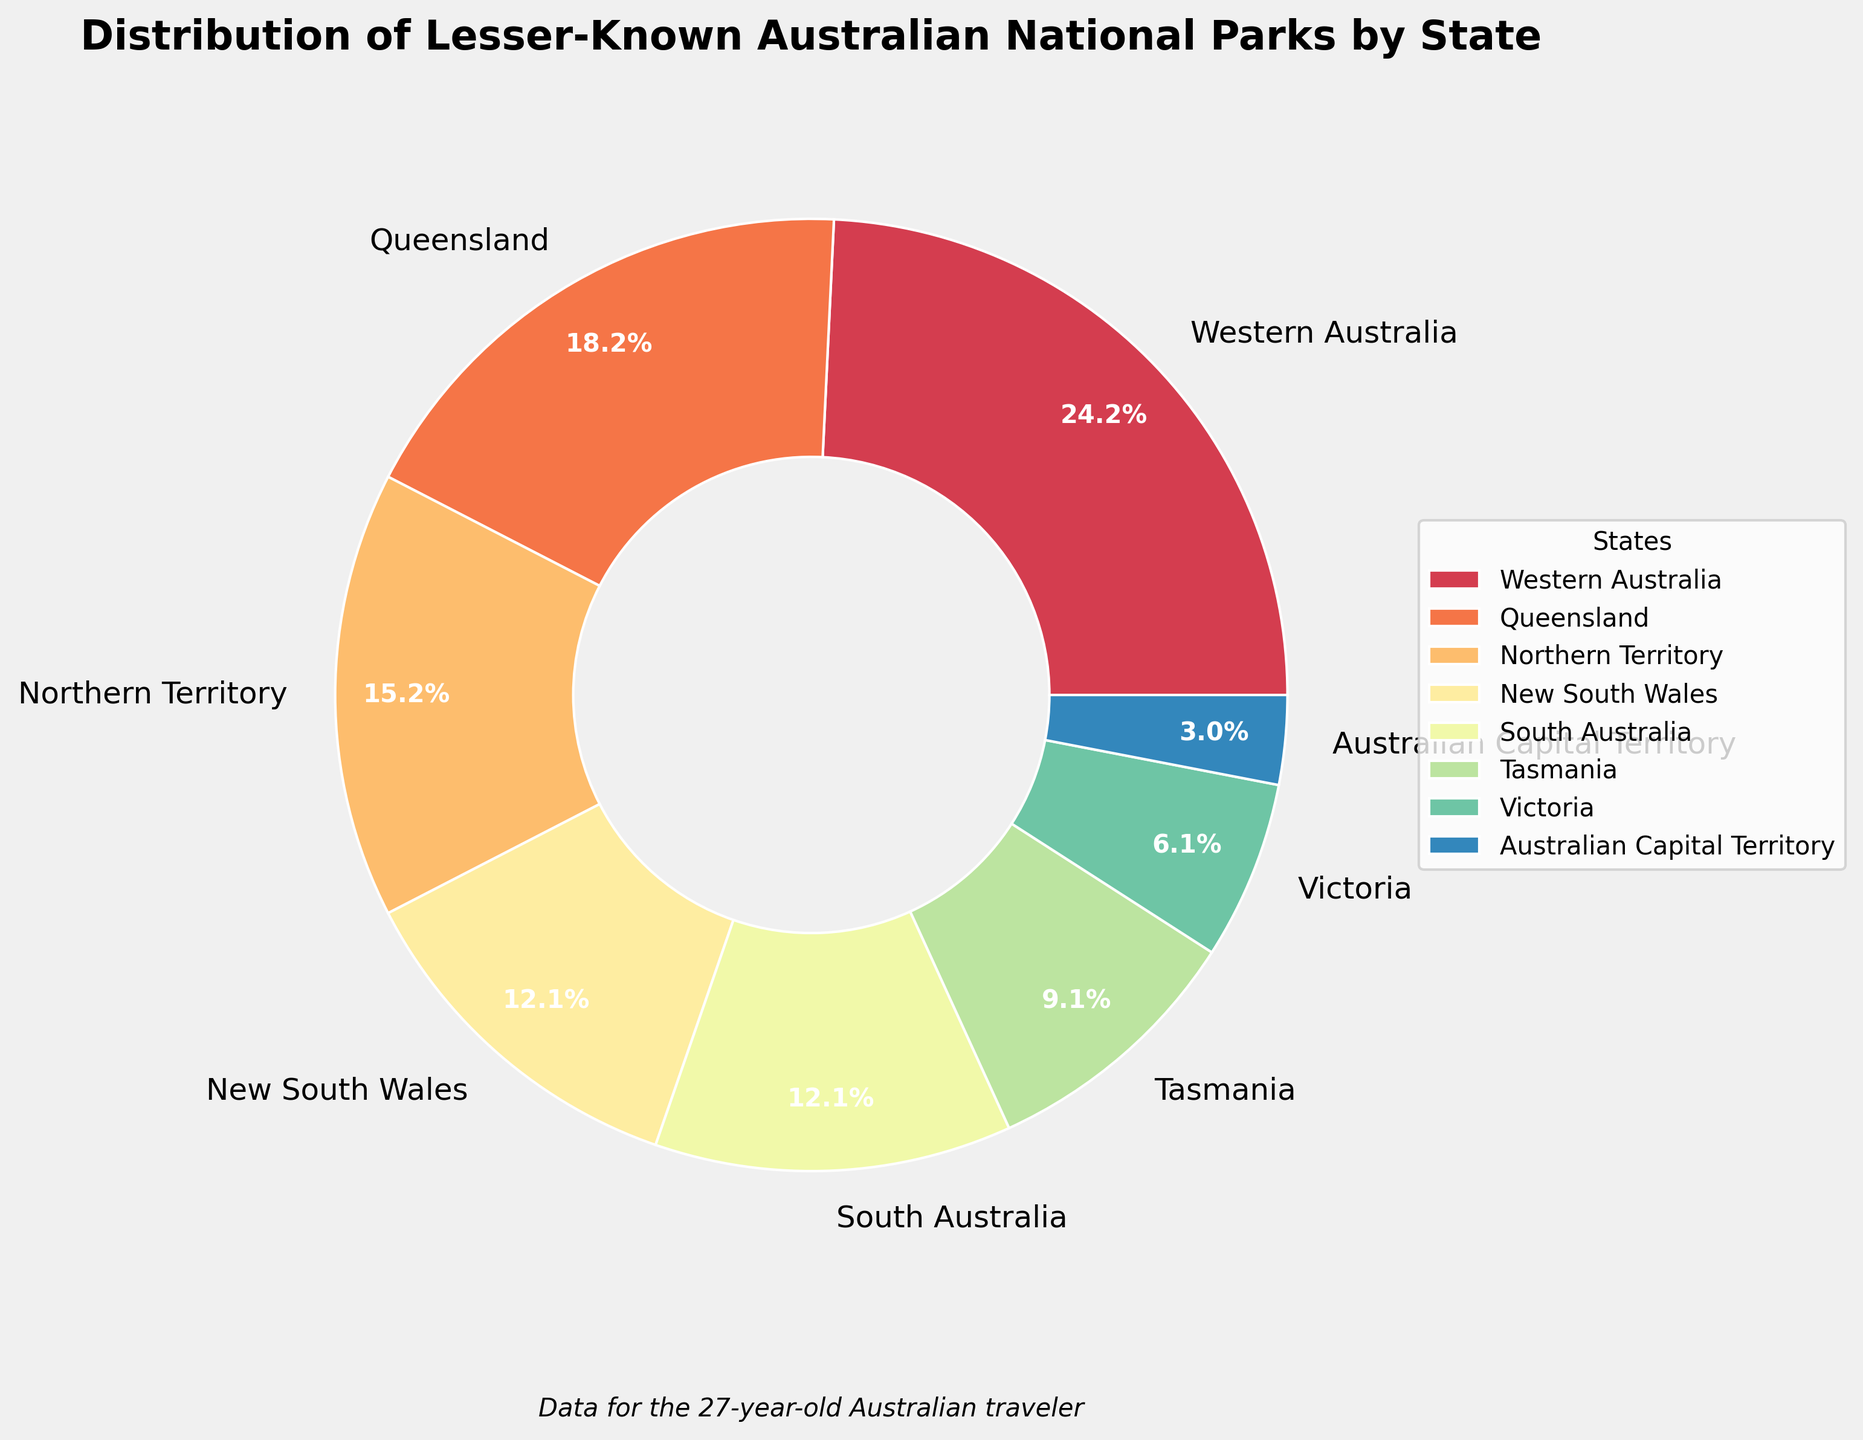Which state has the highest number of lesser-known national parks? The chart shows the distribution of lesser-known national parks by state with labeled percentages. Western Australia has the largest slice.
Answer: Western Australia How many states have exactly 4 lesser-known national parks each? By looking at the data next to the slices in the pie chart, New South Wales and South Australia each have 4 lesser-known national parks.
Answer: 2 What percentage of lesser-known national parks are located in Tasmania? The pie chart labels each slice with its corresponding percentage. The slice for Tasmania shows 12%.
Answer: 12% Which state has fewer lesser-known national parks: Victoria or Tasmania? The pie chart shows the relative sizes of the slices for each state. Victoria's slice is smaller than Tasmania's slice.
Answer: Victoria What is the total number of lesser-known national parks in Western Australia and Queensland combined? Add the number of lesser-known national parks in Western Australia (8) and Queensland (6). 8 + 6 = 14
Answer: 14 Which three states have the smallest number of lesser-known national parks? The pie chart reveals that Victoria, Australian Capital Territory, and Tasmania have the smallest slices, representing 2 parks, 1 park, and 3 parks respectively.
Answer: Victoria, Australian Capital Territory, Tasmania Is the number of lesser-known national parks in Northern Territory greater than the number in Tasmania? According to the pie chart, Northern Territory has a larger slice than Tasmania.
Answer: Yes What is the percentage difference between the number of lesser-known national parks in Northern Territory and New South Wales? Northern Territory has 5 parks and New South Wales has 4 parks. Calculate [(5 - 4) / 5] * 100 = 20%.
Answer: 20% Which state accounts for exactly 5 lesser-known national parks? The pie chart labels the states and their corresponding numbers of parks. Northern Territory is labeled with 5 parks.
Answer: Northern Territory What is the combined percentage of lesser-known national parks in New South Wales and South Australia? Each state is labeled with its percentage in the pie chart. Both New South Wales and South Australia have 10%. Thus, 10% + 10% = 20%.
Answer: 20% 